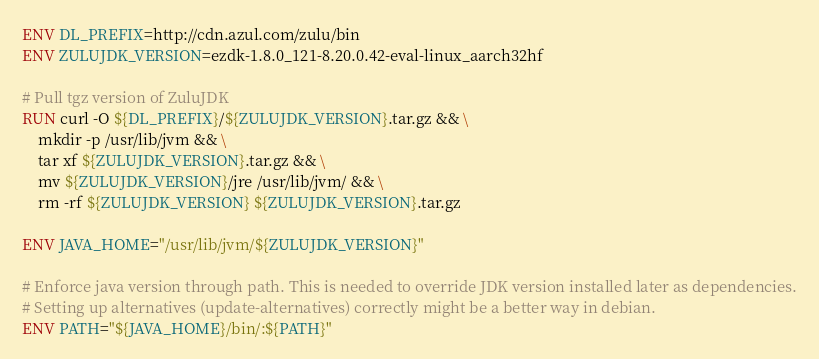Convert code to text. <code><loc_0><loc_0><loc_500><loc_500><_Dockerfile_>
ENV DL_PREFIX=http://cdn.azul.com/zulu/bin
ENV ZULUJDK_VERSION=ezdk-1.8.0_121-8.20.0.42-eval-linux_aarch32hf

# Pull tgz version of ZuluJDK
RUN curl -O ${DL_PREFIX}/${ZULUJDK_VERSION}.tar.gz && \
    mkdir -p /usr/lib/jvm && \
    tar xf ${ZULUJDK_VERSION}.tar.gz && \
    mv ${ZULUJDK_VERSION}/jre /usr/lib/jvm/ && \
    rm -rf ${ZULUJDK_VERSION} ${ZULUJDK_VERSION}.tar.gz

ENV JAVA_HOME="/usr/lib/jvm/${ZULUJDK_VERSION}"

# Enforce java version through path. This is needed to override JDK version installed later as dependencies.
# Setting up alternatives (update-alternatives) correctly might be a better way in debian.
ENV PATH="${JAVA_HOME}/bin/:${PATH}"</code> 